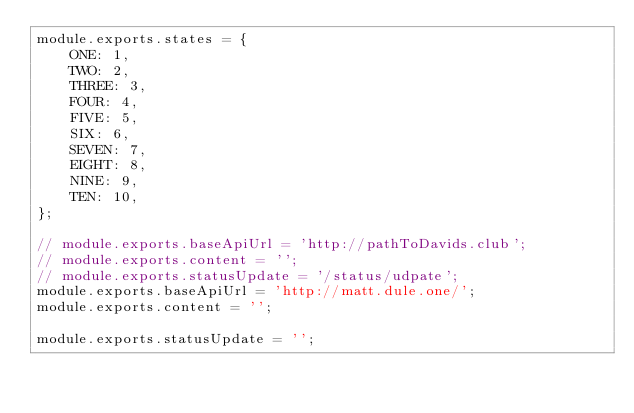<code> <loc_0><loc_0><loc_500><loc_500><_JavaScript_>module.exports.states = {
    ONE: 1,
    TWO: 2,
    THREE: 3,
    FOUR: 4,
    FIVE: 5,
    SIX: 6,
    SEVEN: 7,
    EIGHT: 8,
    NINE: 9,
    TEN: 10,
};

// module.exports.baseApiUrl = 'http://pathToDavids.club';
// module.exports.content = '';
// module.exports.statusUpdate = '/status/udpate';
module.exports.baseApiUrl = 'http://matt.dule.one/';
module.exports.content = '';

module.exports.statusUpdate = '';</code> 